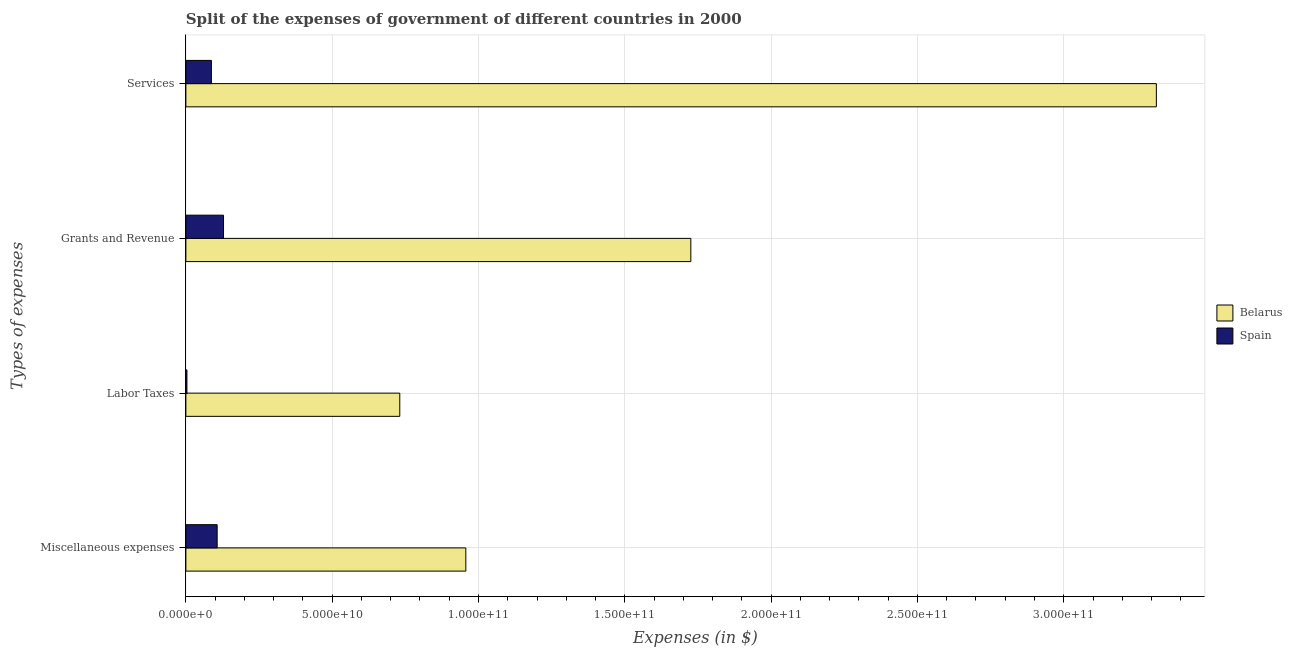How many different coloured bars are there?
Your answer should be very brief. 2. Are the number of bars per tick equal to the number of legend labels?
Offer a very short reply. Yes. Are the number of bars on each tick of the Y-axis equal?
Your response must be concise. Yes. How many bars are there on the 1st tick from the top?
Your answer should be compact. 2. What is the label of the 3rd group of bars from the top?
Provide a short and direct response. Labor Taxes. What is the amount spent on services in Spain?
Your response must be concise. 8.72e+09. Across all countries, what is the maximum amount spent on labor taxes?
Make the answer very short. 7.31e+1. Across all countries, what is the minimum amount spent on grants and revenue?
Ensure brevity in your answer.  1.29e+1. In which country was the amount spent on services maximum?
Give a very brief answer. Belarus. In which country was the amount spent on grants and revenue minimum?
Offer a terse response. Spain. What is the total amount spent on miscellaneous expenses in the graph?
Offer a very short reply. 1.06e+11. What is the difference between the amount spent on miscellaneous expenses in Belarus and that in Spain?
Your answer should be compact. 8.50e+1. What is the difference between the amount spent on labor taxes in Spain and the amount spent on grants and revenue in Belarus?
Your answer should be very brief. -1.72e+11. What is the average amount spent on grants and revenue per country?
Keep it short and to the point. 9.27e+1. What is the difference between the amount spent on services and amount spent on labor taxes in Belarus?
Give a very brief answer. 2.59e+11. In how many countries, is the amount spent on grants and revenue greater than 240000000000 $?
Give a very brief answer. 0. What is the ratio of the amount spent on labor taxes in Spain to that in Belarus?
Offer a terse response. 0. Is the amount spent on labor taxes in Belarus less than that in Spain?
Provide a short and direct response. No. What is the difference between the highest and the second highest amount spent on services?
Your response must be concise. 3.23e+11. What is the difference between the highest and the lowest amount spent on labor taxes?
Your answer should be compact. 7.27e+1. In how many countries, is the amount spent on services greater than the average amount spent on services taken over all countries?
Provide a short and direct response. 1. Is the sum of the amount spent on services in Spain and Belarus greater than the maximum amount spent on labor taxes across all countries?
Your answer should be compact. Yes. What does the 2nd bar from the bottom in Services represents?
Your answer should be compact. Spain. Is it the case that in every country, the sum of the amount spent on miscellaneous expenses and amount spent on labor taxes is greater than the amount spent on grants and revenue?
Provide a succinct answer. No. How many bars are there?
Your response must be concise. 8. Are all the bars in the graph horizontal?
Provide a short and direct response. Yes. How many countries are there in the graph?
Your answer should be compact. 2. Are the values on the major ticks of X-axis written in scientific E-notation?
Keep it short and to the point. Yes. Does the graph contain any zero values?
Your answer should be compact. No. Where does the legend appear in the graph?
Give a very brief answer. Center right. How are the legend labels stacked?
Make the answer very short. Vertical. What is the title of the graph?
Make the answer very short. Split of the expenses of government of different countries in 2000. Does "St. Martin (French part)" appear as one of the legend labels in the graph?
Give a very brief answer. No. What is the label or title of the X-axis?
Give a very brief answer. Expenses (in $). What is the label or title of the Y-axis?
Ensure brevity in your answer.  Types of expenses. What is the Expenses (in $) in Belarus in Miscellaneous expenses?
Ensure brevity in your answer.  9.57e+1. What is the Expenses (in $) in Spain in Miscellaneous expenses?
Your answer should be very brief. 1.07e+1. What is the Expenses (in $) in Belarus in Labor Taxes?
Your response must be concise. 7.31e+1. What is the Expenses (in $) of Spain in Labor Taxes?
Ensure brevity in your answer.  3.55e+08. What is the Expenses (in $) of Belarus in Grants and Revenue?
Offer a very short reply. 1.73e+11. What is the Expenses (in $) in Spain in Grants and Revenue?
Your answer should be very brief. 1.29e+1. What is the Expenses (in $) of Belarus in Services?
Your answer should be compact. 3.32e+11. What is the Expenses (in $) in Spain in Services?
Provide a short and direct response. 8.72e+09. Across all Types of expenses, what is the maximum Expenses (in $) of Belarus?
Provide a short and direct response. 3.32e+11. Across all Types of expenses, what is the maximum Expenses (in $) in Spain?
Offer a very short reply. 1.29e+1. Across all Types of expenses, what is the minimum Expenses (in $) of Belarus?
Your response must be concise. 7.31e+1. Across all Types of expenses, what is the minimum Expenses (in $) in Spain?
Ensure brevity in your answer.  3.55e+08. What is the total Expenses (in $) in Belarus in the graph?
Keep it short and to the point. 6.73e+11. What is the total Expenses (in $) in Spain in the graph?
Offer a terse response. 3.26e+1. What is the difference between the Expenses (in $) of Belarus in Miscellaneous expenses and that in Labor Taxes?
Keep it short and to the point. 2.26e+1. What is the difference between the Expenses (in $) of Spain in Miscellaneous expenses and that in Labor Taxes?
Offer a very short reply. 1.03e+1. What is the difference between the Expenses (in $) of Belarus in Miscellaneous expenses and that in Grants and Revenue?
Give a very brief answer. -7.69e+1. What is the difference between the Expenses (in $) of Spain in Miscellaneous expenses and that in Grants and Revenue?
Your answer should be very brief. -2.18e+09. What is the difference between the Expenses (in $) of Belarus in Miscellaneous expenses and that in Services?
Provide a short and direct response. -2.36e+11. What is the difference between the Expenses (in $) in Spain in Miscellaneous expenses and that in Services?
Offer a terse response. 1.97e+09. What is the difference between the Expenses (in $) of Belarus in Labor Taxes and that in Grants and Revenue?
Provide a short and direct response. -9.95e+1. What is the difference between the Expenses (in $) in Spain in Labor Taxes and that in Grants and Revenue?
Give a very brief answer. -1.25e+1. What is the difference between the Expenses (in $) of Belarus in Labor Taxes and that in Services?
Your answer should be very brief. -2.59e+11. What is the difference between the Expenses (in $) of Spain in Labor Taxes and that in Services?
Keep it short and to the point. -8.37e+09. What is the difference between the Expenses (in $) of Belarus in Grants and Revenue and that in Services?
Make the answer very short. -1.59e+11. What is the difference between the Expenses (in $) in Spain in Grants and Revenue and that in Services?
Offer a very short reply. 4.14e+09. What is the difference between the Expenses (in $) in Belarus in Miscellaneous expenses and the Expenses (in $) in Spain in Labor Taxes?
Your response must be concise. 9.53e+1. What is the difference between the Expenses (in $) in Belarus in Miscellaneous expenses and the Expenses (in $) in Spain in Grants and Revenue?
Your answer should be very brief. 8.28e+1. What is the difference between the Expenses (in $) in Belarus in Miscellaneous expenses and the Expenses (in $) in Spain in Services?
Make the answer very short. 8.69e+1. What is the difference between the Expenses (in $) in Belarus in Labor Taxes and the Expenses (in $) in Spain in Grants and Revenue?
Offer a very short reply. 6.02e+1. What is the difference between the Expenses (in $) in Belarus in Labor Taxes and the Expenses (in $) in Spain in Services?
Keep it short and to the point. 6.44e+1. What is the difference between the Expenses (in $) in Belarus in Grants and Revenue and the Expenses (in $) in Spain in Services?
Offer a terse response. 1.64e+11. What is the average Expenses (in $) in Belarus per Types of expenses?
Provide a succinct answer. 1.68e+11. What is the average Expenses (in $) in Spain per Types of expenses?
Your answer should be very brief. 8.16e+09. What is the difference between the Expenses (in $) of Belarus and Expenses (in $) of Spain in Miscellaneous expenses?
Give a very brief answer. 8.50e+1. What is the difference between the Expenses (in $) in Belarus and Expenses (in $) in Spain in Labor Taxes?
Make the answer very short. 7.27e+1. What is the difference between the Expenses (in $) of Belarus and Expenses (in $) of Spain in Grants and Revenue?
Ensure brevity in your answer.  1.60e+11. What is the difference between the Expenses (in $) of Belarus and Expenses (in $) of Spain in Services?
Your answer should be very brief. 3.23e+11. What is the ratio of the Expenses (in $) in Belarus in Miscellaneous expenses to that in Labor Taxes?
Ensure brevity in your answer.  1.31. What is the ratio of the Expenses (in $) of Spain in Miscellaneous expenses to that in Labor Taxes?
Give a very brief answer. 30.11. What is the ratio of the Expenses (in $) of Belarus in Miscellaneous expenses to that in Grants and Revenue?
Ensure brevity in your answer.  0.55. What is the ratio of the Expenses (in $) of Spain in Miscellaneous expenses to that in Grants and Revenue?
Ensure brevity in your answer.  0.83. What is the ratio of the Expenses (in $) of Belarus in Miscellaneous expenses to that in Services?
Make the answer very short. 0.29. What is the ratio of the Expenses (in $) of Spain in Miscellaneous expenses to that in Services?
Provide a short and direct response. 1.23. What is the ratio of the Expenses (in $) of Belarus in Labor Taxes to that in Grants and Revenue?
Give a very brief answer. 0.42. What is the ratio of the Expenses (in $) of Spain in Labor Taxes to that in Grants and Revenue?
Ensure brevity in your answer.  0.03. What is the ratio of the Expenses (in $) of Belarus in Labor Taxes to that in Services?
Your answer should be very brief. 0.22. What is the ratio of the Expenses (in $) of Spain in Labor Taxes to that in Services?
Keep it short and to the point. 0.04. What is the ratio of the Expenses (in $) of Belarus in Grants and Revenue to that in Services?
Provide a succinct answer. 0.52. What is the ratio of the Expenses (in $) of Spain in Grants and Revenue to that in Services?
Give a very brief answer. 1.48. What is the difference between the highest and the second highest Expenses (in $) of Belarus?
Your answer should be very brief. 1.59e+11. What is the difference between the highest and the second highest Expenses (in $) of Spain?
Ensure brevity in your answer.  2.18e+09. What is the difference between the highest and the lowest Expenses (in $) in Belarus?
Your answer should be compact. 2.59e+11. What is the difference between the highest and the lowest Expenses (in $) in Spain?
Ensure brevity in your answer.  1.25e+1. 